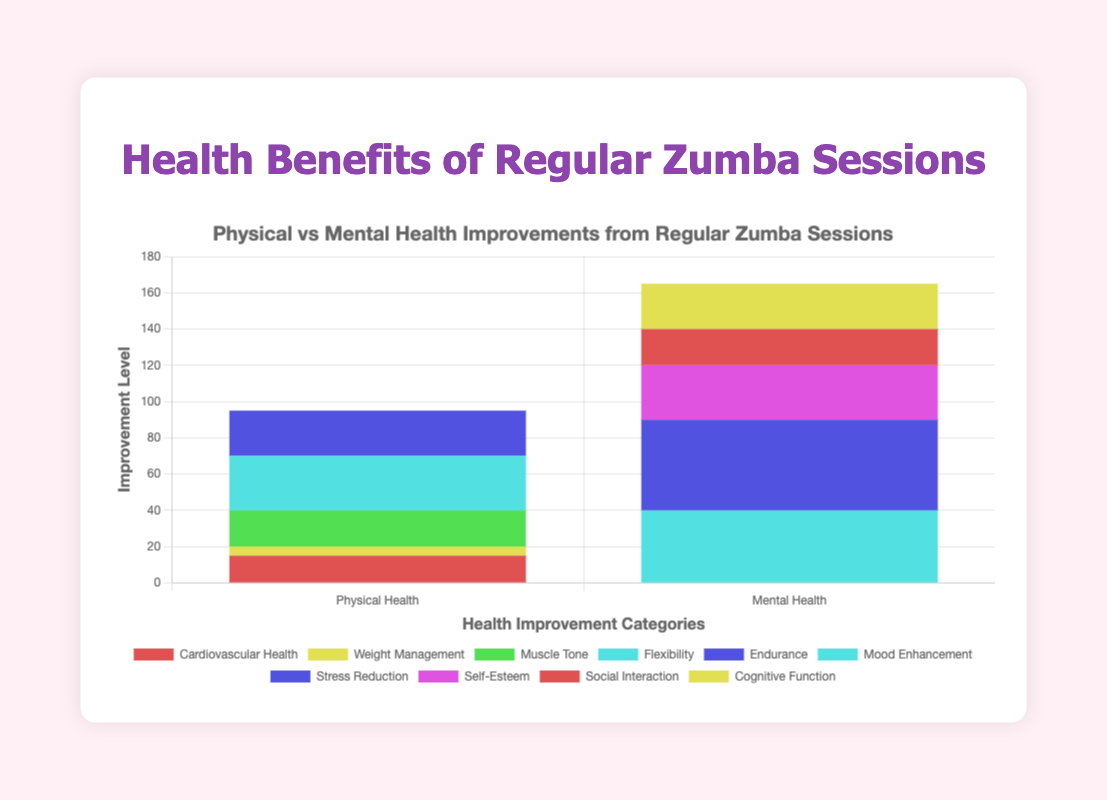What is the total improvement in all categories of Physical Health Improvements? The categories of Physical Health Improvements are Cardiovascular Health (15), Weight Management (5), Muscle Tone (20), Flexibility (30), and Endurance (25). Total improvement = 15 + 5 + 20 + 30 + 25 = 95.
Answer: 95 Which category has the highest improvement in the Mental Health Improvements? The categories of Mental Health Improvements are Mood Enhancement (40), Stress Reduction (50), Self-Esteem (30), Social Interaction (20), and Cognitive Function (25). Stress Reduction has the highest improvement, which is 50.
Answer: Stress Reduction Which category experiences more improvement: Cardiovascular Health or Muscle Tone? Cardiovascular Health has an improvement of 15, while Muscle Tone has an improvement of 20. Muscle Tone has a higher improvement.
Answer: Muscle Tone How much greater is the improvement in Flexibility compared to Weight Management? Flexibility shows an improvement of 30, and Weight Management shows an improvement of 5. The difference is 30 - 5 = 25.
Answer: 25 What is the average improvement in categories of Mental Health Improvements? The Mental Health categories have improvements of 40, 50, 30, 20, and 25. Average improvement = (40 + 50 + 30 + 20 + 25) / 5 = 165 / 5 = 33.
Answer: 33 How does the improvement in Endurance compare to Cognitive Function? Endurance has an improvement of 25, and Cognitive Function also has an improvement of 25. Both have equal improvements.
Answer: Equal From which visual attribute can you infer the category with the highest improvement? The category Stress Reduction in the Mental Health Improvements has the highest bar height, indicating the highest improvement.
Answer: Highest bar, Stress Reduction Are there more categories with improvements in Physical Health or Mental Health? The chart lists 5 categories for Physical Health Improvements and 5 categories for Mental Health Improvements. Both have the same number of categories.
Answer: Equal number What is the difference between the highest improvement in Physical Health and Mental Health categories? Highest improvement in Physical Health is Flexibility with 30, and in Mental Health is Stress Reduction with 50. The difference is 50 - 30 = 20.
Answer: 20 